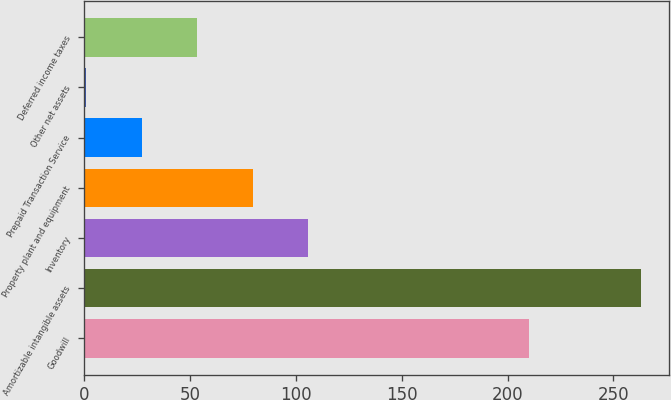<chart> <loc_0><loc_0><loc_500><loc_500><bar_chart><fcel>Goodwill<fcel>Amortizable intangible assets<fcel>Inventory<fcel>Property plant and equipment<fcel>Prepaid Transaction Service<fcel>Other net assets<fcel>Deferred income taxes<nl><fcel>210<fcel>263<fcel>105.8<fcel>79.6<fcel>27.2<fcel>1<fcel>53.4<nl></chart> 